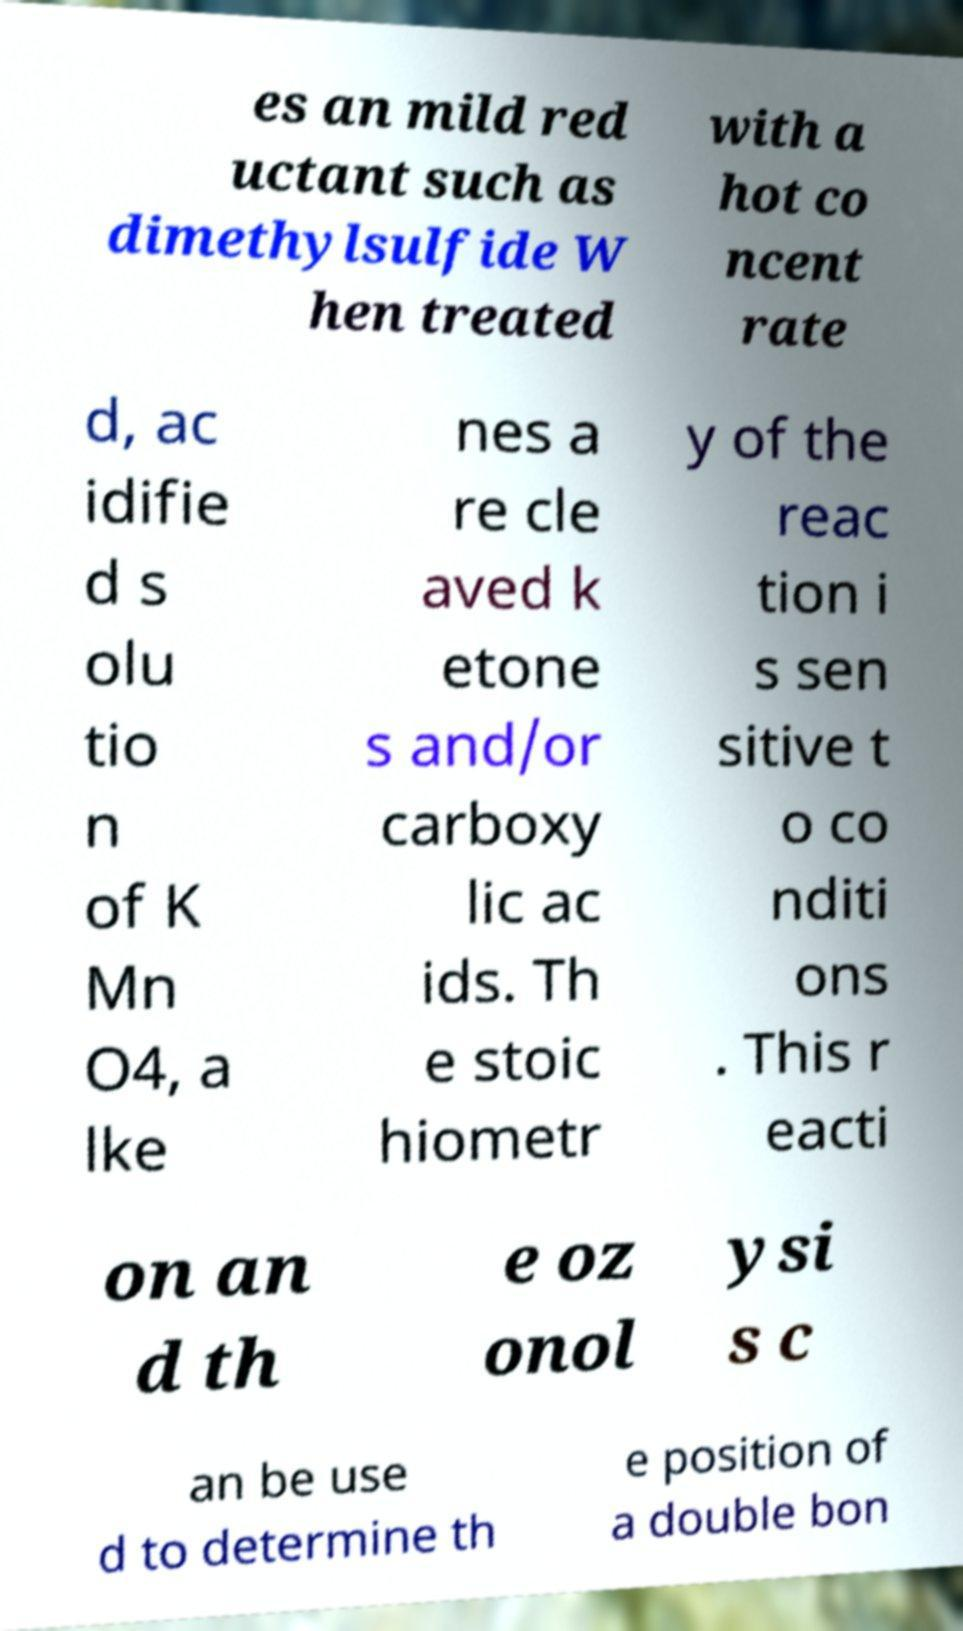Could you assist in decoding the text presented in this image and type it out clearly? es an mild red uctant such as dimethylsulfide W hen treated with a hot co ncent rate d, ac idifie d s olu tio n of K Mn O4, a lke nes a re cle aved k etone s and/or carboxy lic ac ids. Th e stoic hiometr y of the reac tion i s sen sitive t o co nditi ons . This r eacti on an d th e oz onol ysi s c an be use d to determine th e position of a double bon 